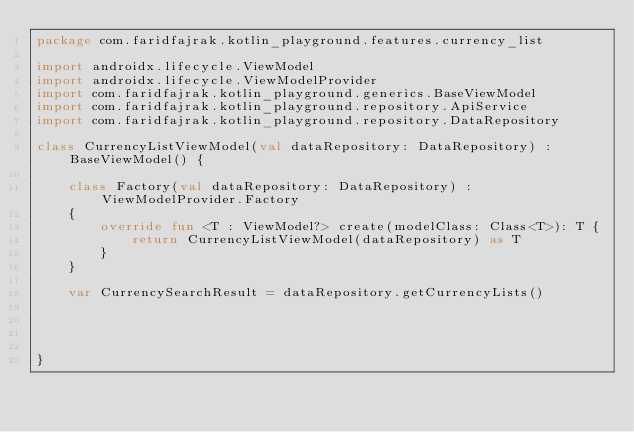Convert code to text. <code><loc_0><loc_0><loc_500><loc_500><_Kotlin_>package com.faridfajrak.kotlin_playground.features.currency_list

import androidx.lifecycle.ViewModel
import androidx.lifecycle.ViewModelProvider
import com.faridfajrak.kotlin_playground.generics.BaseViewModel
import com.faridfajrak.kotlin_playground.repository.ApiService
import com.faridfajrak.kotlin_playground.repository.DataRepository

class CurrencyListViewModel(val dataRepository: DataRepository) : BaseViewModel() {

    class Factory(val dataRepository: DataRepository) : ViewModelProvider.Factory
    {
        override fun <T : ViewModel?> create(modelClass: Class<T>): T {
            return CurrencyListViewModel(dataRepository) as T
        }
    }

    var CurrencySearchResult = dataRepository.getCurrencyLists()




}</code> 